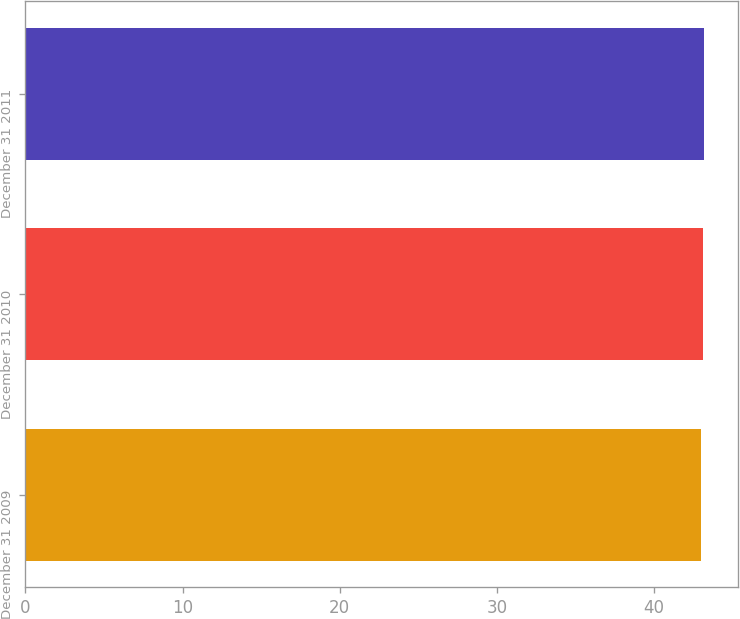Convert chart. <chart><loc_0><loc_0><loc_500><loc_500><bar_chart><fcel>December 31 2009<fcel>December 31 2010<fcel>December 31 2011<nl><fcel>43<fcel>43.1<fcel>43.2<nl></chart> 